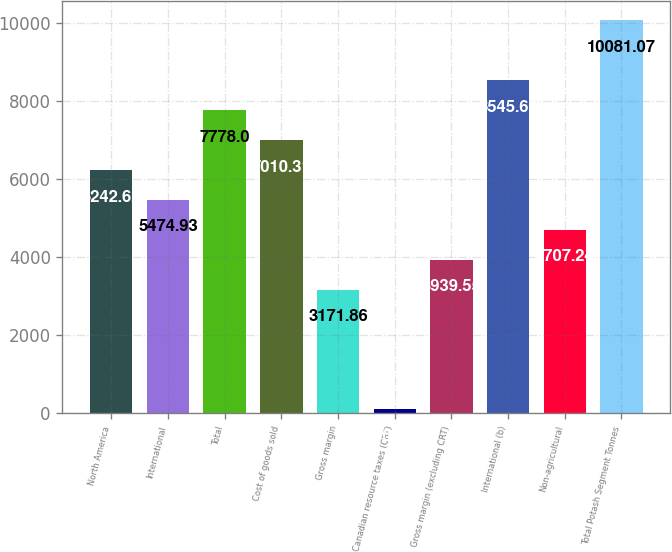<chart> <loc_0><loc_0><loc_500><loc_500><bar_chart><fcel>North America<fcel>International<fcel>Total<fcel>Cost of goods sold<fcel>Gross margin<fcel>Canadian resource taxes (CRT)<fcel>Gross margin (excluding CRT)<fcel>International (b)<fcel>Non-agricultural<fcel>Total Potash Segment Tonnes<nl><fcel>6242.62<fcel>5474.93<fcel>7778<fcel>7010.31<fcel>3171.86<fcel>101.1<fcel>3939.55<fcel>8545.69<fcel>4707.24<fcel>10081.1<nl></chart> 